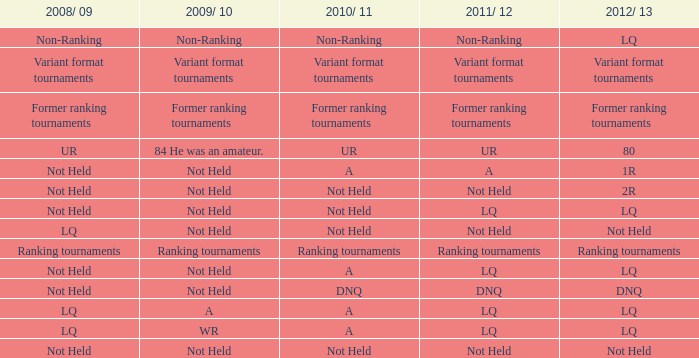When the 2008/ 09 has non-ranking what is the 2009/ 10? Non-Ranking. 